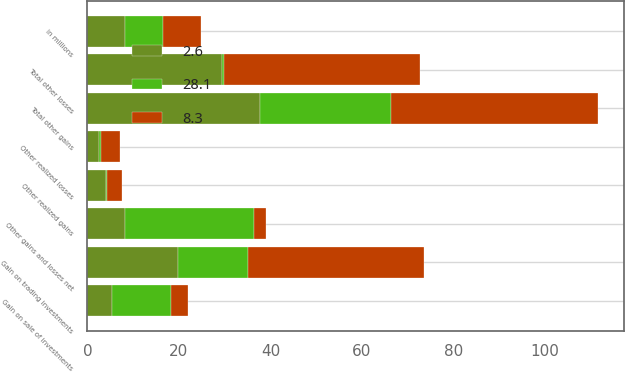Convert chart. <chart><loc_0><loc_0><loc_500><loc_500><stacked_bar_chart><ecel><fcel>in millions<fcel>Gain on sale of investments<fcel>Gain on trading investments<fcel>Other realized gains<fcel>Total other gains<fcel>Other realized losses<fcel>Total other losses<fcel>Other gains and losses net<nl><fcel>28.1<fcel>8.3<fcel>13<fcel>15.4<fcel>0.2<fcel>28.6<fcel>0.3<fcel>0.5<fcel>28.1<nl><fcel>8.3<fcel>8.3<fcel>3.6<fcel>38.5<fcel>3.2<fcel>45.3<fcel>4.3<fcel>42.7<fcel>2.6<nl><fcel>2.6<fcel>8.3<fcel>5.3<fcel>19.7<fcel>4.1<fcel>37.7<fcel>2.6<fcel>29.4<fcel>8.3<nl></chart> 